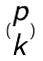Convert formula to latex. <formula><loc_0><loc_0><loc_500><loc_500>( \begin{matrix} p \\ k \end{matrix} )</formula> 